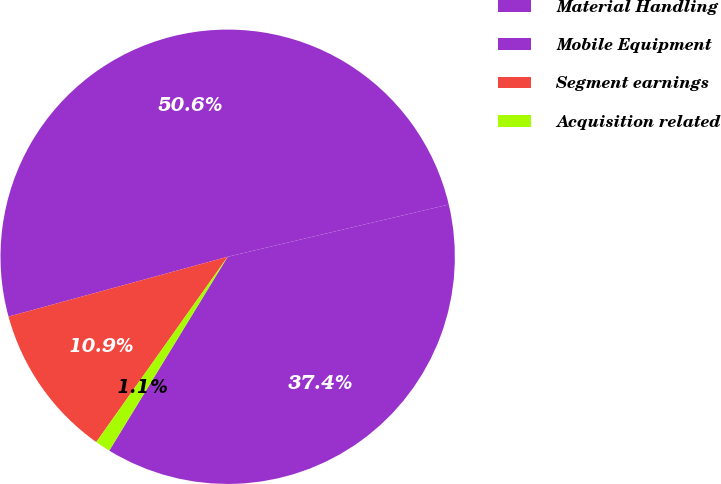<chart> <loc_0><loc_0><loc_500><loc_500><pie_chart><fcel>Material Handling<fcel>Mobile Equipment<fcel>Segment earnings<fcel>Acquisition related<nl><fcel>37.42%<fcel>50.55%<fcel>10.94%<fcel>1.09%<nl></chart> 